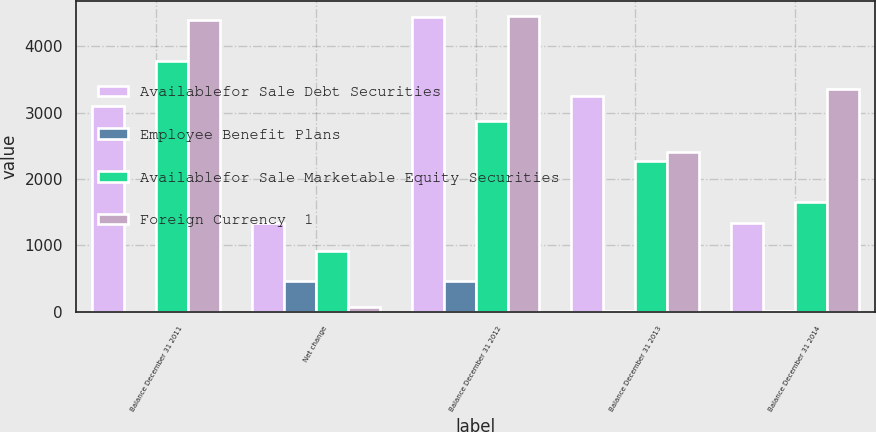Convert chart to OTSL. <chart><loc_0><loc_0><loc_500><loc_500><stacked_bar_chart><ecel><fcel>Balance December 31 2011<fcel>Net change<fcel>Balance December 31 2012<fcel>Balance December 31 2013<fcel>Balance December 31 2014<nl><fcel>Availablefor Sale Debt Securities<fcel>3100<fcel>1343<fcel>4443<fcel>3257<fcel>1343<nl><fcel>Employee Benefit Plans<fcel>3<fcel>459<fcel>462<fcel>4<fcel>17<nl><fcel>Availablefor Sale Marketable Equity Securities<fcel>3785<fcel>916<fcel>2869<fcel>2277<fcel>1661<nl><fcel>Foreign Currency  1<fcel>4391<fcel>65<fcel>4456<fcel>2407<fcel>3350<nl></chart> 